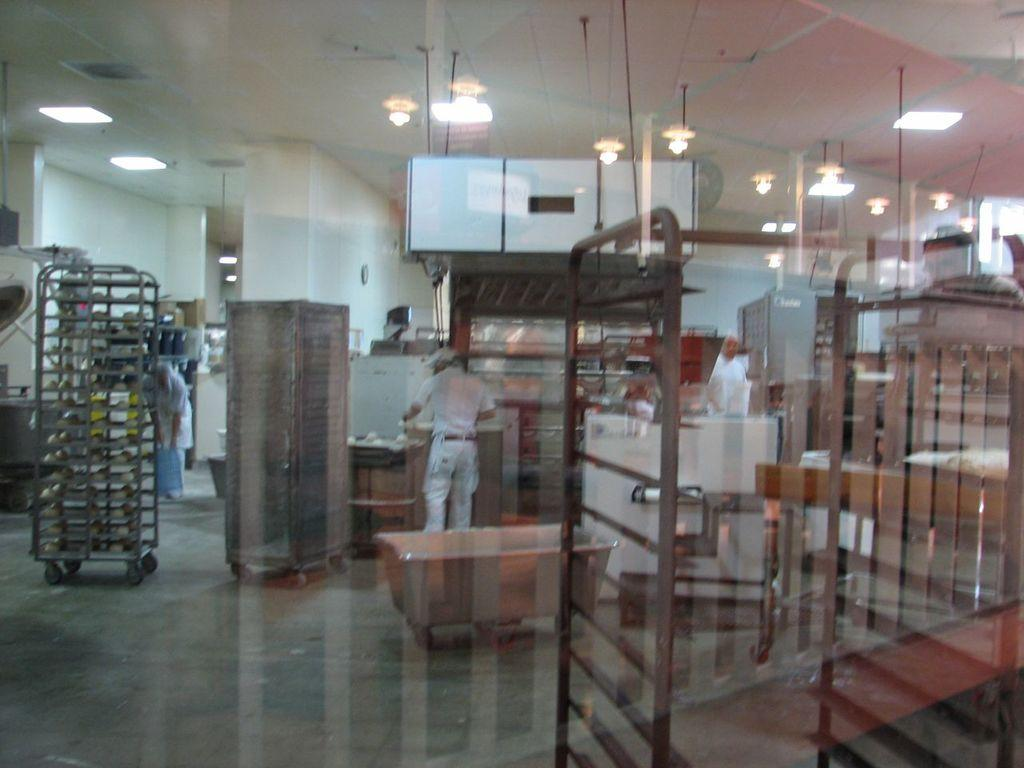What are the people in the image doing? The people in the image are standing on the floor. What can be seen on the left side of the image? There is a trolley on the left side of the image. What is present on the floor in the image? There are objects on the floor. What is attached to the roof in the image? Lights are attached to the roof at the top of the image. Where is the horse located in the image? There is no horse present in the image. What type of class is being taught in the image? There is no class or teaching activity depicted in the image. 